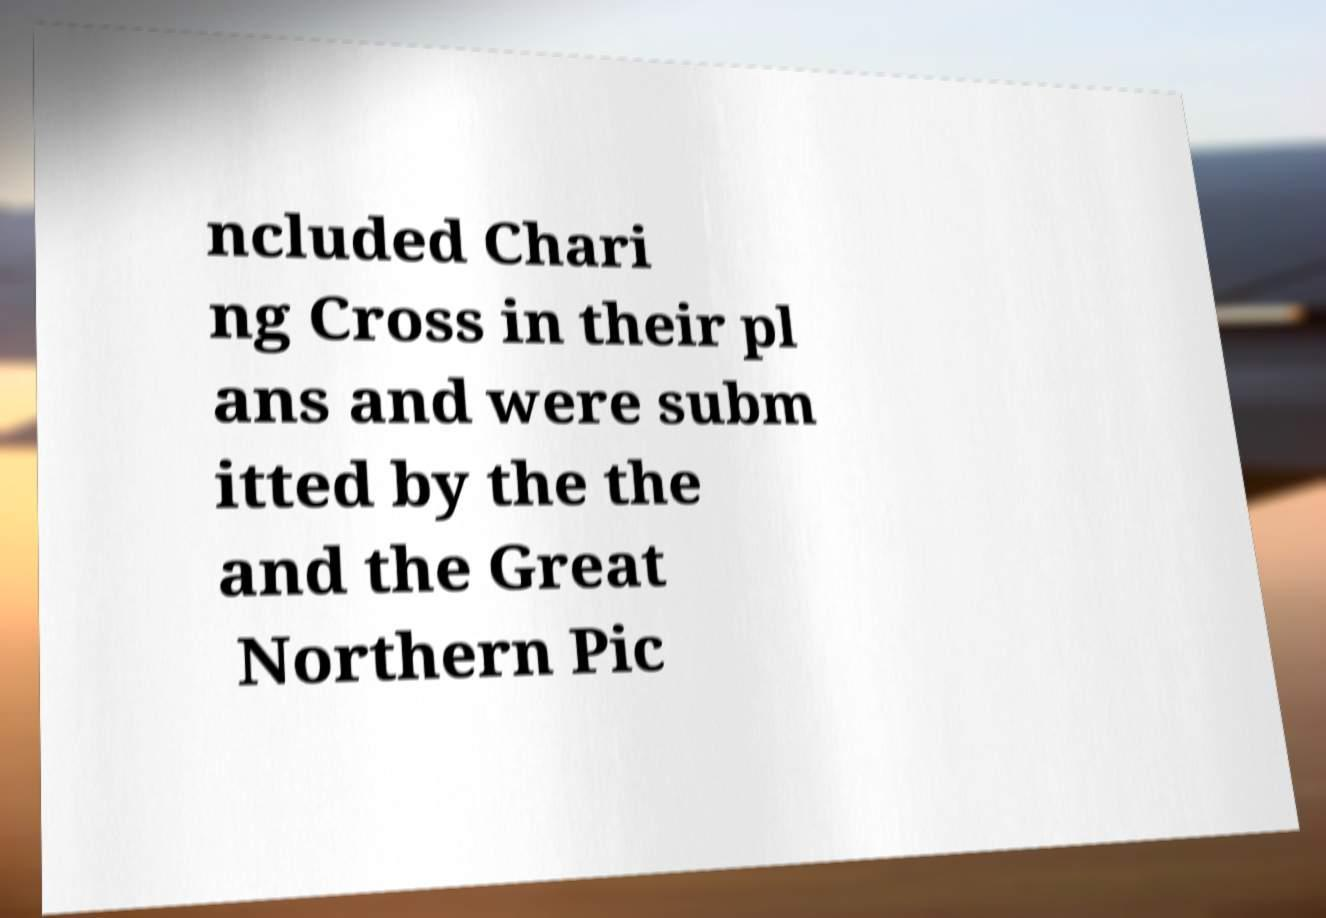Can you read and provide the text displayed in the image?This photo seems to have some interesting text. Can you extract and type it out for me? ncluded Chari ng Cross in their pl ans and were subm itted by the the and the Great Northern Pic 